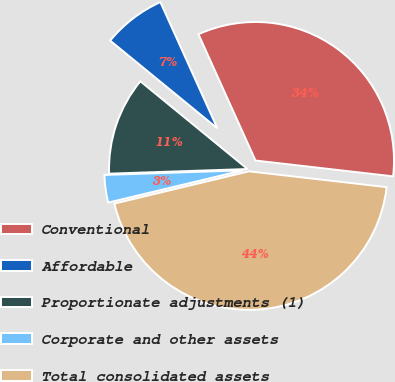Convert chart. <chart><loc_0><loc_0><loc_500><loc_500><pie_chart><fcel>Conventional<fcel>Affordable<fcel>Proportionate adjustments (1)<fcel>Corporate and other assets<fcel>Total consolidated assets<nl><fcel>33.57%<fcel>7.33%<fcel>11.45%<fcel>3.21%<fcel>44.43%<nl></chart> 